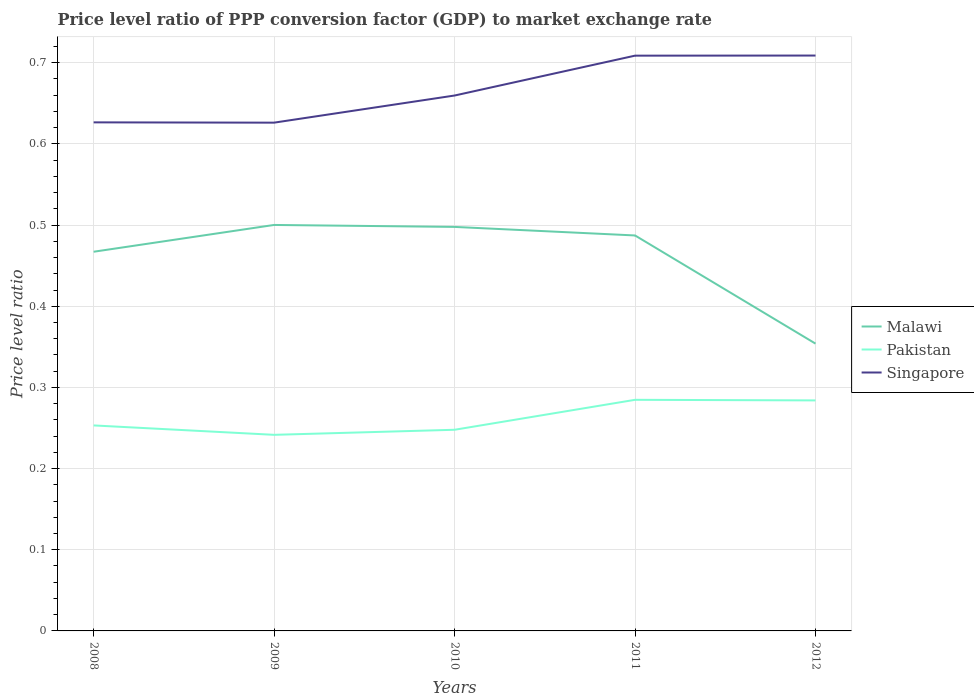How many different coloured lines are there?
Give a very brief answer. 3. Across all years, what is the maximum price level ratio in Malawi?
Provide a succinct answer. 0.35. In which year was the price level ratio in Singapore maximum?
Provide a short and direct response. 2009. What is the total price level ratio in Malawi in the graph?
Keep it short and to the point. 0.01. What is the difference between the highest and the second highest price level ratio in Malawi?
Provide a short and direct response. 0.15. What is the difference between two consecutive major ticks on the Y-axis?
Provide a short and direct response. 0.1. Does the graph contain any zero values?
Keep it short and to the point. No. Where does the legend appear in the graph?
Ensure brevity in your answer.  Center right. How many legend labels are there?
Make the answer very short. 3. How are the legend labels stacked?
Your response must be concise. Vertical. What is the title of the graph?
Offer a terse response. Price level ratio of PPP conversion factor (GDP) to market exchange rate. What is the label or title of the Y-axis?
Provide a succinct answer. Price level ratio. What is the Price level ratio in Malawi in 2008?
Provide a short and direct response. 0.47. What is the Price level ratio of Pakistan in 2008?
Provide a succinct answer. 0.25. What is the Price level ratio in Singapore in 2008?
Keep it short and to the point. 0.63. What is the Price level ratio of Malawi in 2009?
Your response must be concise. 0.5. What is the Price level ratio in Pakistan in 2009?
Ensure brevity in your answer.  0.24. What is the Price level ratio in Singapore in 2009?
Ensure brevity in your answer.  0.63. What is the Price level ratio of Malawi in 2010?
Your response must be concise. 0.5. What is the Price level ratio of Pakistan in 2010?
Provide a short and direct response. 0.25. What is the Price level ratio of Singapore in 2010?
Keep it short and to the point. 0.66. What is the Price level ratio of Malawi in 2011?
Your answer should be very brief. 0.49. What is the Price level ratio in Pakistan in 2011?
Keep it short and to the point. 0.28. What is the Price level ratio in Singapore in 2011?
Give a very brief answer. 0.71. What is the Price level ratio in Malawi in 2012?
Your answer should be compact. 0.35. What is the Price level ratio in Pakistan in 2012?
Your answer should be compact. 0.28. What is the Price level ratio in Singapore in 2012?
Offer a terse response. 0.71. Across all years, what is the maximum Price level ratio in Malawi?
Your response must be concise. 0.5. Across all years, what is the maximum Price level ratio of Pakistan?
Your response must be concise. 0.28. Across all years, what is the maximum Price level ratio of Singapore?
Your response must be concise. 0.71. Across all years, what is the minimum Price level ratio in Malawi?
Your answer should be compact. 0.35. Across all years, what is the minimum Price level ratio of Pakistan?
Ensure brevity in your answer.  0.24. Across all years, what is the minimum Price level ratio in Singapore?
Ensure brevity in your answer.  0.63. What is the total Price level ratio in Malawi in the graph?
Offer a very short reply. 2.31. What is the total Price level ratio of Pakistan in the graph?
Provide a short and direct response. 1.31. What is the total Price level ratio in Singapore in the graph?
Your response must be concise. 3.33. What is the difference between the Price level ratio in Malawi in 2008 and that in 2009?
Give a very brief answer. -0.03. What is the difference between the Price level ratio of Pakistan in 2008 and that in 2009?
Provide a short and direct response. 0.01. What is the difference between the Price level ratio in Malawi in 2008 and that in 2010?
Your response must be concise. -0.03. What is the difference between the Price level ratio of Pakistan in 2008 and that in 2010?
Provide a short and direct response. 0.01. What is the difference between the Price level ratio of Singapore in 2008 and that in 2010?
Offer a terse response. -0.03. What is the difference between the Price level ratio in Malawi in 2008 and that in 2011?
Keep it short and to the point. -0.02. What is the difference between the Price level ratio of Pakistan in 2008 and that in 2011?
Make the answer very short. -0.03. What is the difference between the Price level ratio in Singapore in 2008 and that in 2011?
Provide a short and direct response. -0.08. What is the difference between the Price level ratio of Malawi in 2008 and that in 2012?
Make the answer very short. 0.11. What is the difference between the Price level ratio in Pakistan in 2008 and that in 2012?
Keep it short and to the point. -0.03. What is the difference between the Price level ratio of Singapore in 2008 and that in 2012?
Your answer should be very brief. -0.08. What is the difference between the Price level ratio in Malawi in 2009 and that in 2010?
Offer a terse response. 0. What is the difference between the Price level ratio of Pakistan in 2009 and that in 2010?
Your response must be concise. -0.01. What is the difference between the Price level ratio of Singapore in 2009 and that in 2010?
Your answer should be very brief. -0.03. What is the difference between the Price level ratio of Malawi in 2009 and that in 2011?
Give a very brief answer. 0.01. What is the difference between the Price level ratio of Pakistan in 2009 and that in 2011?
Keep it short and to the point. -0.04. What is the difference between the Price level ratio in Singapore in 2009 and that in 2011?
Ensure brevity in your answer.  -0.08. What is the difference between the Price level ratio of Malawi in 2009 and that in 2012?
Make the answer very short. 0.15. What is the difference between the Price level ratio in Pakistan in 2009 and that in 2012?
Make the answer very short. -0.04. What is the difference between the Price level ratio in Singapore in 2009 and that in 2012?
Keep it short and to the point. -0.08. What is the difference between the Price level ratio in Malawi in 2010 and that in 2011?
Make the answer very short. 0.01. What is the difference between the Price level ratio in Pakistan in 2010 and that in 2011?
Your answer should be very brief. -0.04. What is the difference between the Price level ratio in Singapore in 2010 and that in 2011?
Your answer should be compact. -0.05. What is the difference between the Price level ratio of Malawi in 2010 and that in 2012?
Provide a succinct answer. 0.14. What is the difference between the Price level ratio of Pakistan in 2010 and that in 2012?
Provide a succinct answer. -0.04. What is the difference between the Price level ratio in Singapore in 2010 and that in 2012?
Your answer should be very brief. -0.05. What is the difference between the Price level ratio of Malawi in 2011 and that in 2012?
Provide a succinct answer. 0.13. What is the difference between the Price level ratio in Pakistan in 2011 and that in 2012?
Offer a very short reply. 0. What is the difference between the Price level ratio of Singapore in 2011 and that in 2012?
Make the answer very short. -0. What is the difference between the Price level ratio of Malawi in 2008 and the Price level ratio of Pakistan in 2009?
Your response must be concise. 0.23. What is the difference between the Price level ratio in Malawi in 2008 and the Price level ratio in Singapore in 2009?
Your answer should be very brief. -0.16. What is the difference between the Price level ratio of Pakistan in 2008 and the Price level ratio of Singapore in 2009?
Give a very brief answer. -0.37. What is the difference between the Price level ratio in Malawi in 2008 and the Price level ratio in Pakistan in 2010?
Your answer should be compact. 0.22. What is the difference between the Price level ratio in Malawi in 2008 and the Price level ratio in Singapore in 2010?
Give a very brief answer. -0.19. What is the difference between the Price level ratio of Pakistan in 2008 and the Price level ratio of Singapore in 2010?
Make the answer very short. -0.41. What is the difference between the Price level ratio of Malawi in 2008 and the Price level ratio of Pakistan in 2011?
Offer a very short reply. 0.18. What is the difference between the Price level ratio in Malawi in 2008 and the Price level ratio in Singapore in 2011?
Ensure brevity in your answer.  -0.24. What is the difference between the Price level ratio of Pakistan in 2008 and the Price level ratio of Singapore in 2011?
Ensure brevity in your answer.  -0.46. What is the difference between the Price level ratio in Malawi in 2008 and the Price level ratio in Pakistan in 2012?
Your answer should be very brief. 0.18. What is the difference between the Price level ratio of Malawi in 2008 and the Price level ratio of Singapore in 2012?
Your answer should be compact. -0.24. What is the difference between the Price level ratio of Pakistan in 2008 and the Price level ratio of Singapore in 2012?
Provide a short and direct response. -0.46. What is the difference between the Price level ratio of Malawi in 2009 and the Price level ratio of Pakistan in 2010?
Your answer should be very brief. 0.25. What is the difference between the Price level ratio of Malawi in 2009 and the Price level ratio of Singapore in 2010?
Your answer should be compact. -0.16. What is the difference between the Price level ratio of Pakistan in 2009 and the Price level ratio of Singapore in 2010?
Keep it short and to the point. -0.42. What is the difference between the Price level ratio of Malawi in 2009 and the Price level ratio of Pakistan in 2011?
Keep it short and to the point. 0.22. What is the difference between the Price level ratio of Malawi in 2009 and the Price level ratio of Singapore in 2011?
Your answer should be compact. -0.21. What is the difference between the Price level ratio of Pakistan in 2009 and the Price level ratio of Singapore in 2011?
Provide a succinct answer. -0.47. What is the difference between the Price level ratio of Malawi in 2009 and the Price level ratio of Pakistan in 2012?
Make the answer very short. 0.22. What is the difference between the Price level ratio of Malawi in 2009 and the Price level ratio of Singapore in 2012?
Make the answer very short. -0.21. What is the difference between the Price level ratio of Pakistan in 2009 and the Price level ratio of Singapore in 2012?
Provide a succinct answer. -0.47. What is the difference between the Price level ratio of Malawi in 2010 and the Price level ratio of Pakistan in 2011?
Offer a very short reply. 0.21. What is the difference between the Price level ratio in Malawi in 2010 and the Price level ratio in Singapore in 2011?
Give a very brief answer. -0.21. What is the difference between the Price level ratio in Pakistan in 2010 and the Price level ratio in Singapore in 2011?
Offer a terse response. -0.46. What is the difference between the Price level ratio of Malawi in 2010 and the Price level ratio of Pakistan in 2012?
Ensure brevity in your answer.  0.21. What is the difference between the Price level ratio in Malawi in 2010 and the Price level ratio in Singapore in 2012?
Ensure brevity in your answer.  -0.21. What is the difference between the Price level ratio of Pakistan in 2010 and the Price level ratio of Singapore in 2012?
Provide a succinct answer. -0.46. What is the difference between the Price level ratio of Malawi in 2011 and the Price level ratio of Pakistan in 2012?
Provide a succinct answer. 0.2. What is the difference between the Price level ratio of Malawi in 2011 and the Price level ratio of Singapore in 2012?
Give a very brief answer. -0.22. What is the difference between the Price level ratio in Pakistan in 2011 and the Price level ratio in Singapore in 2012?
Provide a succinct answer. -0.42. What is the average Price level ratio of Malawi per year?
Offer a terse response. 0.46. What is the average Price level ratio of Pakistan per year?
Offer a terse response. 0.26. What is the average Price level ratio in Singapore per year?
Offer a terse response. 0.67. In the year 2008, what is the difference between the Price level ratio of Malawi and Price level ratio of Pakistan?
Provide a succinct answer. 0.21. In the year 2008, what is the difference between the Price level ratio in Malawi and Price level ratio in Singapore?
Offer a terse response. -0.16. In the year 2008, what is the difference between the Price level ratio of Pakistan and Price level ratio of Singapore?
Give a very brief answer. -0.37. In the year 2009, what is the difference between the Price level ratio of Malawi and Price level ratio of Pakistan?
Provide a succinct answer. 0.26. In the year 2009, what is the difference between the Price level ratio in Malawi and Price level ratio in Singapore?
Keep it short and to the point. -0.13. In the year 2009, what is the difference between the Price level ratio in Pakistan and Price level ratio in Singapore?
Offer a very short reply. -0.38. In the year 2010, what is the difference between the Price level ratio of Malawi and Price level ratio of Pakistan?
Your answer should be very brief. 0.25. In the year 2010, what is the difference between the Price level ratio of Malawi and Price level ratio of Singapore?
Your response must be concise. -0.16. In the year 2010, what is the difference between the Price level ratio in Pakistan and Price level ratio in Singapore?
Your response must be concise. -0.41. In the year 2011, what is the difference between the Price level ratio in Malawi and Price level ratio in Pakistan?
Keep it short and to the point. 0.2. In the year 2011, what is the difference between the Price level ratio in Malawi and Price level ratio in Singapore?
Provide a short and direct response. -0.22. In the year 2011, what is the difference between the Price level ratio in Pakistan and Price level ratio in Singapore?
Your answer should be compact. -0.42. In the year 2012, what is the difference between the Price level ratio of Malawi and Price level ratio of Pakistan?
Keep it short and to the point. 0.07. In the year 2012, what is the difference between the Price level ratio in Malawi and Price level ratio in Singapore?
Your answer should be very brief. -0.35. In the year 2012, what is the difference between the Price level ratio in Pakistan and Price level ratio in Singapore?
Your response must be concise. -0.42. What is the ratio of the Price level ratio of Malawi in 2008 to that in 2009?
Your answer should be compact. 0.93. What is the ratio of the Price level ratio in Pakistan in 2008 to that in 2009?
Your answer should be compact. 1.05. What is the ratio of the Price level ratio in Malawi in 2008 to that in 2010?
Make the answer very short. 0.94. What is the ratio of the Price level ratio in Pakistan in 2008 to that in 2010?
Your response must be concise. 1.02. What is the ratio of the Price level ratio in Singapore in 2008 to that in 2010?
Ensure brevity in your answer.  0.95. What is the ratio of the Price level ratio in Malawi in 2008 to that in 2011?
Your answer should be very brief. 0.96. What is the ratio of the Price level ratio in Pakistan in 2008 to that in 2011?
Your answer should be compact. 0.89. What is the ratio of the Price level ratio of Singapore in 2008 to that in 2011?
Provide a short and direct response. 0.88. What is the ratio of the Price level ratio in Malawi in 2008 to that in 2012?
Provide a short and direct response. 1.32. What is the ratio of the Price level ratio of Pakistan in 2008 to that in 2012?
Your answer should be very brief. 0.89. What is the ratio of the Price level ratio of Singapore in 2008 to that in 2012?
Provide a short and direct response. 0.88. What is the ratio of the Price level ratio of Malawi in 2009 to that in 2010?
Provide a short and direct response. 1. What is the ratio of the Price level ratio of Pakistan in 2009 to that in 2010?
Keep it short and to the point. 0.97. What is the ratio of the Price level ratio of Singapore in 2009 to that in 2010?
Make the answer very short. 0.95. What is the ratio of the Price level ratio of Malawi in 2009 to that in 2011?
Make the answer very short. 1.03. What is the ratio of the Price level ratio of Pakistan in 2009 to that in 2011?
Ensure brevity in your answer.  0.85. What is the ratio of the Price level ratio in Singapore in 2009 to that in 2011?
Your answer should be very brief. 0.88. What is the ratio of the Price level ratio of Malawi in 2009 to that in 2012?
Give a very brief answer. 1.41. What is the ratio of the Price level ratio of Pakistan in 2009 to that in 2012?
Offer a very short reply. 0.85. What is the ratio of the Price level ratio of Singapore in 2009 to that in 2012?
Provide a succinct answer. 0.88. What is the ratio of the Price level ratio of Malawi in 2010 to that in 2011?
Give a very brief answer. 1.02. What is the ratio of the Price level ratio in Pakistan in 2010 to that in 2011?
Offer a terse response. 0.87. What is the ratio of the Price level ratio of Singapore in 2010 to that in 2011?
Your answer should be very brief. 0.93. What is the ratio of the Price level ratio in Malawi in 2010 to that in 2012?
Your answer should be very brief. 1.41. What is the ratio of the Price level ratio of Pakistan in 2010 to that in 2012?
Keep it short and to the point. 0.87. What is the ratio of the Price level ratio in Singapore in 2010 to that in 2012?
Your answer should be very brief. 0.93. What is the ratio of the Price level ratio of Malawi in 2011 to that in 2012?
Give a very brief answer. 1.38. What is the difference between the highest and the second highest Price level ratio of Malawi?
Offer a terse response. 0. What is the difference between the highest and the second highest Price level ratio in Pakistan?
Offer a very short reply. 0. What is the difference between the highest and the second highest Price level ratio of Singapore?
Offer a terse response. 0. What is the difference between the highest and the lowest Price level ratio in Malawi?
Keep it short and to the point. 0.15. What is the difference between the highest and the lowest Price level ratio in Pakistan?
Ensure brevity in your answer.  0.04. What is the difference between the highest and the lowest Price level ratio in Singapore?
Offer a very short reply. 0.08. 